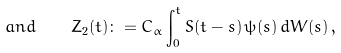<formula> <loc_0><loc_0><loc_500><loc_500>a n d \quad Z _ { 2 } ( t ) \colon = C _ { \alpha } \int _ { 0 } ^ { t } S ( t - s ) \, \psi ( s ) \, d W ( s ) \, ,</formula> 